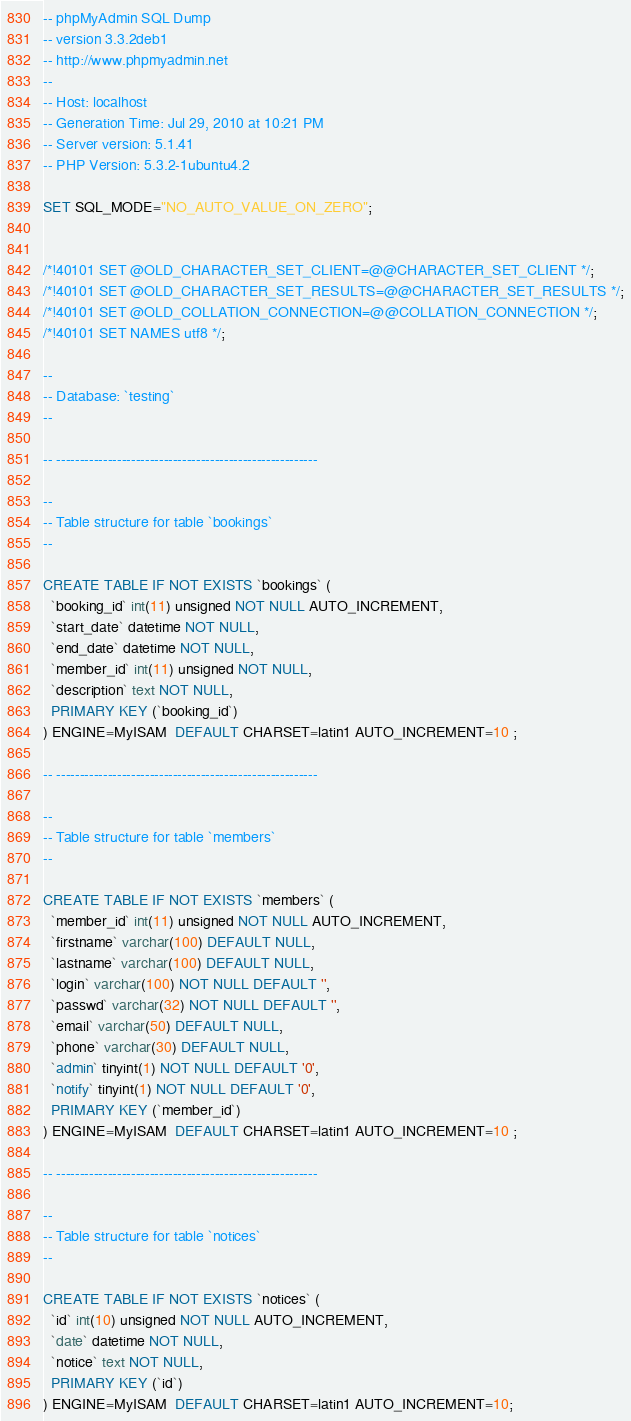Convert code to text. <code><loc_0><loc_0><loc_500><loc_500><_SQL_>-- phpMyAdmin SQL Dump
-- version 3.3.2deb1
-- http://www.phpmyadmin.net
--
-- Host: localhost
-- Generation Time: Jul 29, 2010 at 10:21 PM
-- Server version: 5.1.41
-- PHP Version: 5.3.2-1ubuntu4.2

SET SQL_MODE="NO_AUTO_VALUE_ON_ZERO";


/*!40101 SET @OLD_CHARACTER_SET_CLIENT=@@CHARACTER_SET_CLIENT */;
/*!40101 SET @OLD_CHARACTER_SET_RESULTS=@@CHARACTER_SET_RESULTS */;
/*!40101 SET @OLD_COLLATION_CONNECTION=@@COLLATION_CONNECTION */;
/*!40101 SET NAMES utf8 */;

--
-- Database: `testing`
--

-- --------------------------------------------------------

--
-- Table structure for table `bookings`
--

CREATE TABLE IF NOT EXISTS `bookings` (
  `booking_id` int(11) unsigned NOT NULL AUTO_INCREMENT,
  `start_date` datetime NOT NULL,
  `end_date` datetime NOT NULL,
  `member_id` int(11) unsigned NOT NULL,
  `description` text NOT NULL,
  PRIMARY KEY (`booking_id`)
) ENGINE=MyISAM  DEFAULT CHARSET=latin1 AUTO_INCREMENT=10 ;

-- --------------------------------------------------------

--
-- Table structure for table `members`
--

CREATE TABLE IF NOT EXISTS `members` (
  `member_id` int(11) unsigned NOT NULL AUTO_INCREMENT,
  `firstname` varchar(100) DEFAULT NULL,
  `lastname` varchar(100) DEFAULT NULL,
  `login` varchar(100) NOT NULL DEFAULT '',
  `passwd` varchar(32) NOT NULL DEFAULT '',
  `email` varchar(50) DEFAULT NULL,
  `phone` varchar(30) DEFAULT NULL,
  `admin` tinyint(1) NOT NULL DEFAULT '0',
  `notify` tinyint(1) NOT NULL DEFAULT '0',
  PRIMARY KEY (`member_id`)
) ENGINE=MyISAM  DEFAULT CHARSET=latin1 AUTO_INCREMENT=10 ;

-- --------------------------------------------------------

--
-- Table structure for table `notices`
--

CREATE TABLE IF NOT EXISTS `notices` (
  `id` int(10) unsigned NOT NULL AUTO_INCREMENT,
  `date` datetime NOT NULL,
  `notice` text NOT NULL,
  PRIMARY KEY (`id`)
) ENGINE=MyISAM  DEFAULT CHARSET=latin1 AUTO_INCREMENT=10;
</code> 